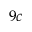<formula> <loc_0><loc_0><loc_500><loc_500>9 c</formula> 